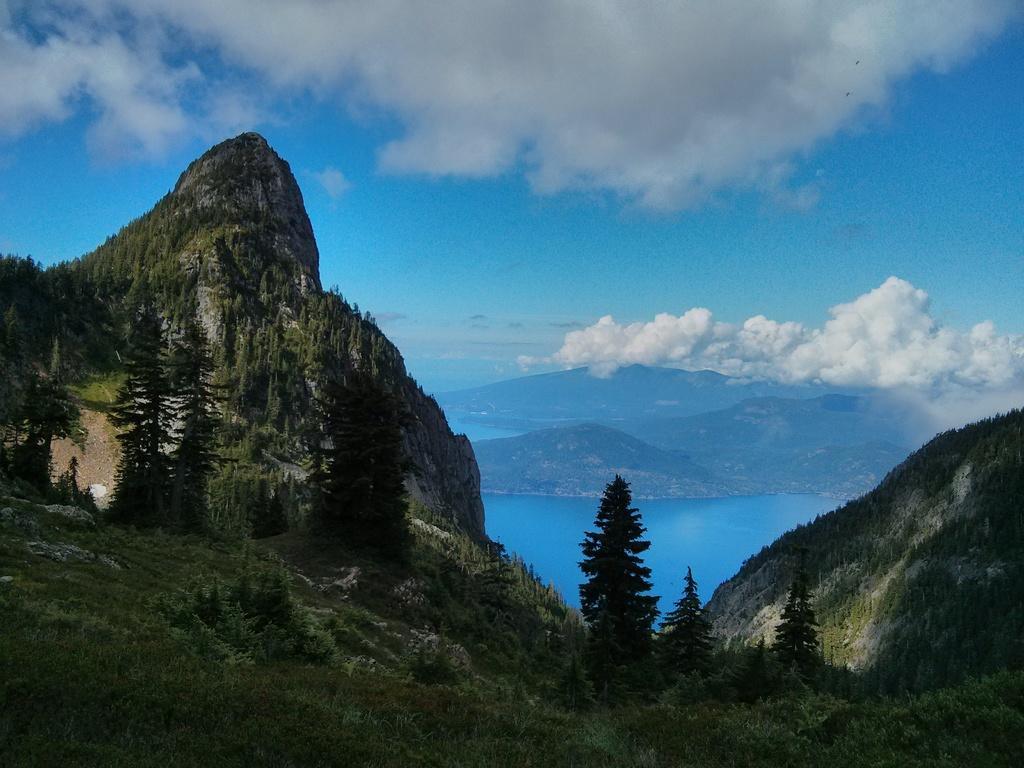Can you describe this image briefly? In this picture we can see grass, plants, and trees. This is water and there is a mountain. In the background there is sky with heavy clouds. 